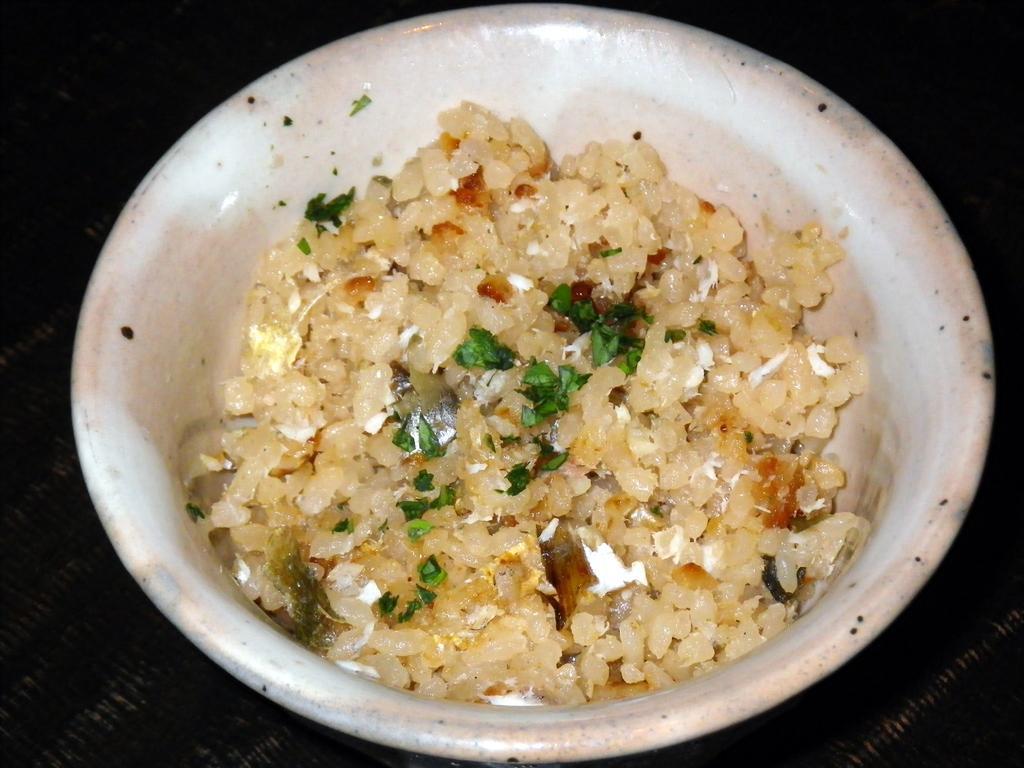In one or two sentences, can you explain what this image depicts? In this image, we can see food in the plate which is placed on the table. 